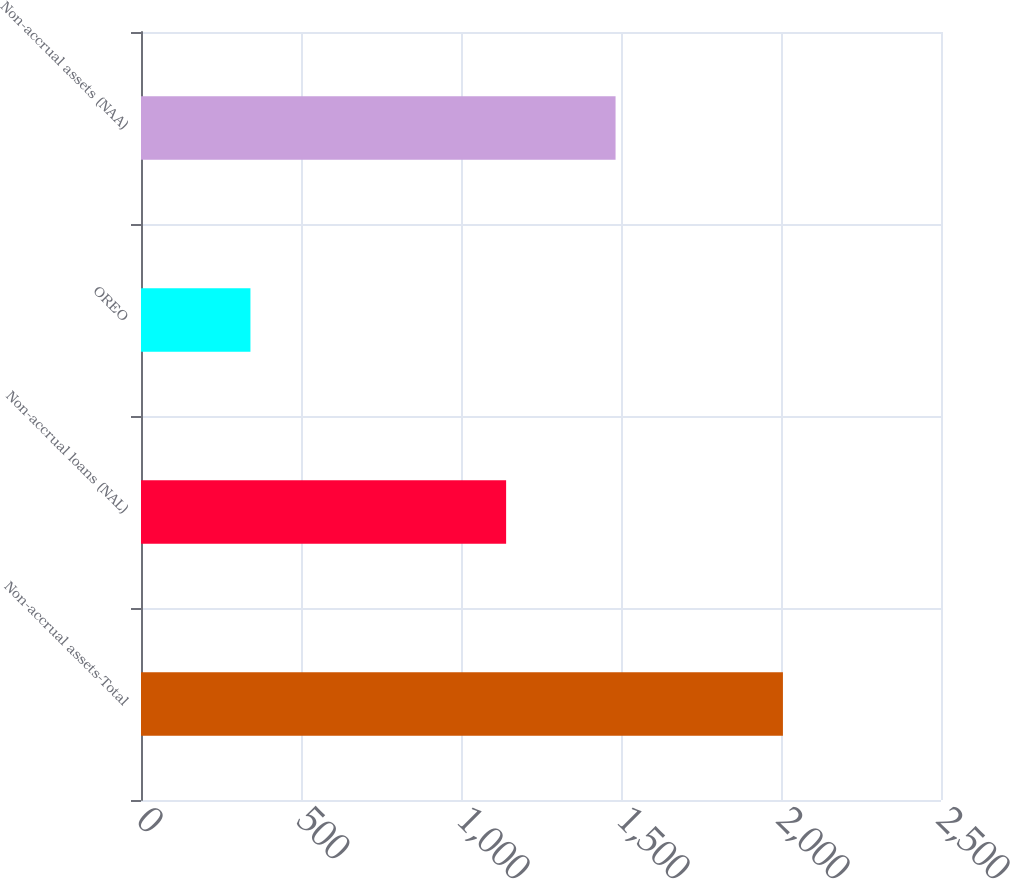<chart> <loc_0><loc_0><loc_500><loc_500><bar_chart><fcel>Non-accrual assets-Total<fcel>Non-accrual loans (NAL)<fcel>OREO<fcel>Non-accrual assets (NAA)<nl><fcel>2006<fcel>1141<fcel>342<fcel>1483<nl></chart> 